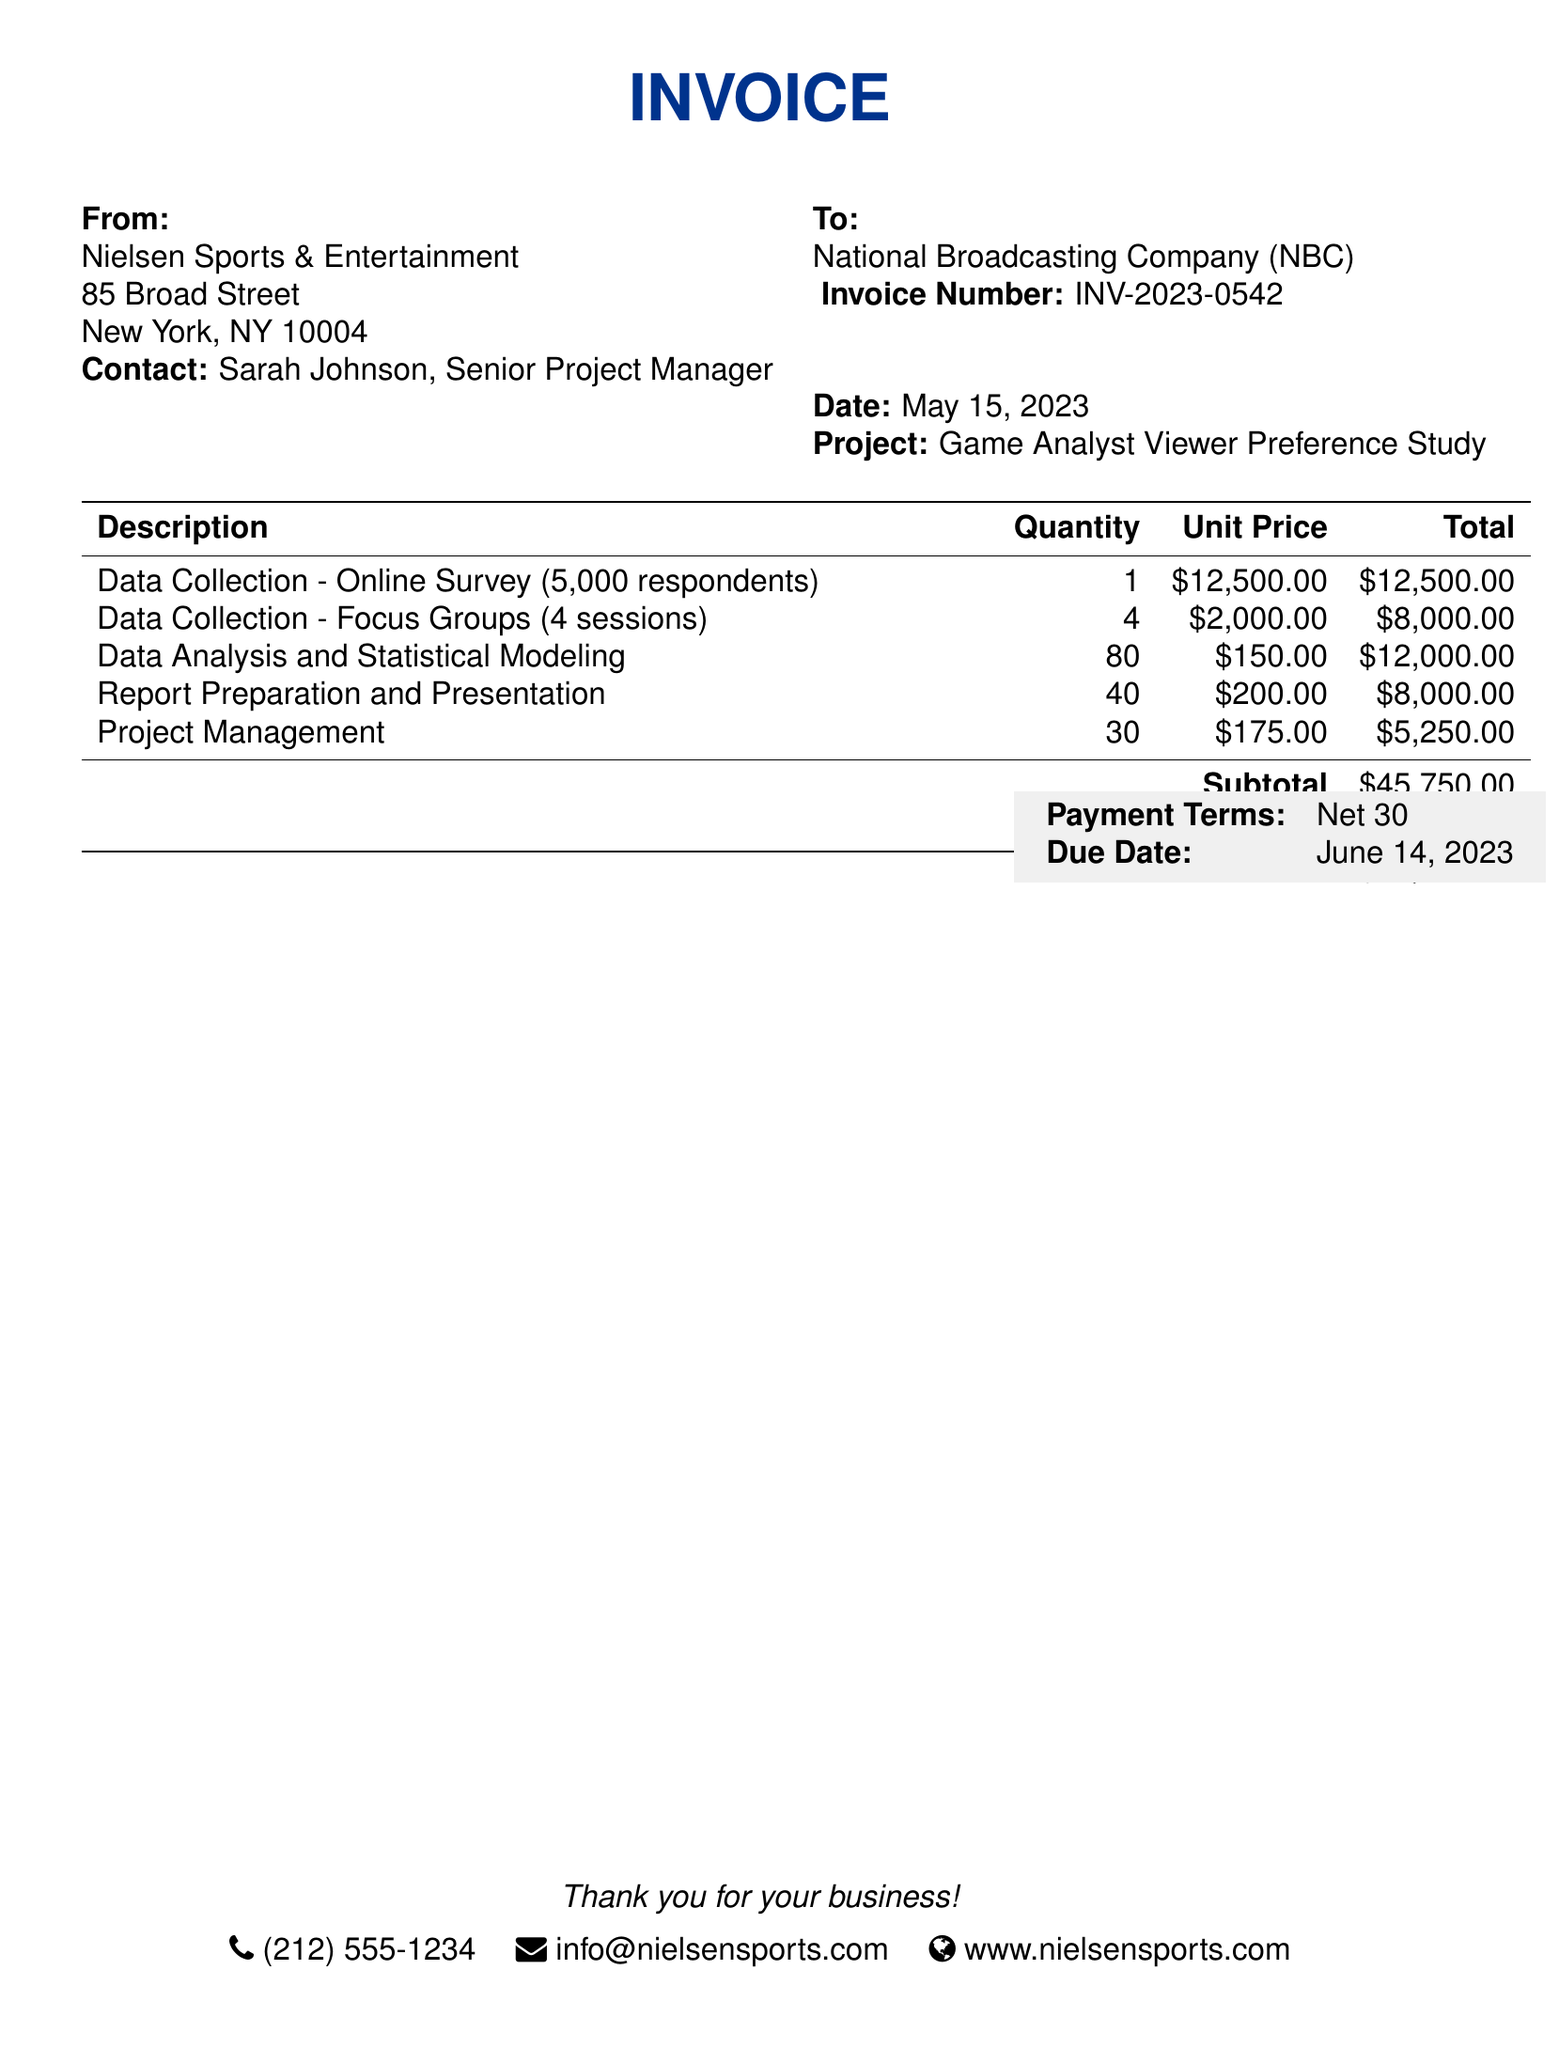What is the invoice number? The invoice number is mentioned directly in the document under "To:" section.
Answer: INV-2023-0542 Who is the contact person at Nielsen Sports & Entertainment? The contact person's name is listed in the "From:" section of the invoice.
Answer: Sarah Johnson What is the total amount due? The total due is provided at the bottom of the table as the final charge for the services rendered.
Answer: $49,410.00 What is the date of the invoice? The date of the invoice is specified directly under the "To:" section.
Answer: May 15, 2023 How many online survey respondents were included in the study? The number of respondents is stated in the description for data collection in the table.
Answer: 5,000 respondents What is the subtotal amount before tax? The subtotal amount is summarized in the invoice before tax is added, indicated in the summary section.
Answer: $45,750.00 What is the tax rate applied to the invoice? The tax rate can be found in the tax line of the invoice that calculates the tax based on the subtotal.
Answer: 8% How many sessions were conducted for focus groups? The number of sessions is listed in the description of the focus groups in the table.
Answer: 4 sessions What are the payment terms stated in the document? The payment terms are documented in the light gray box towards the bottom of the invoice.
Answer: Net 30 